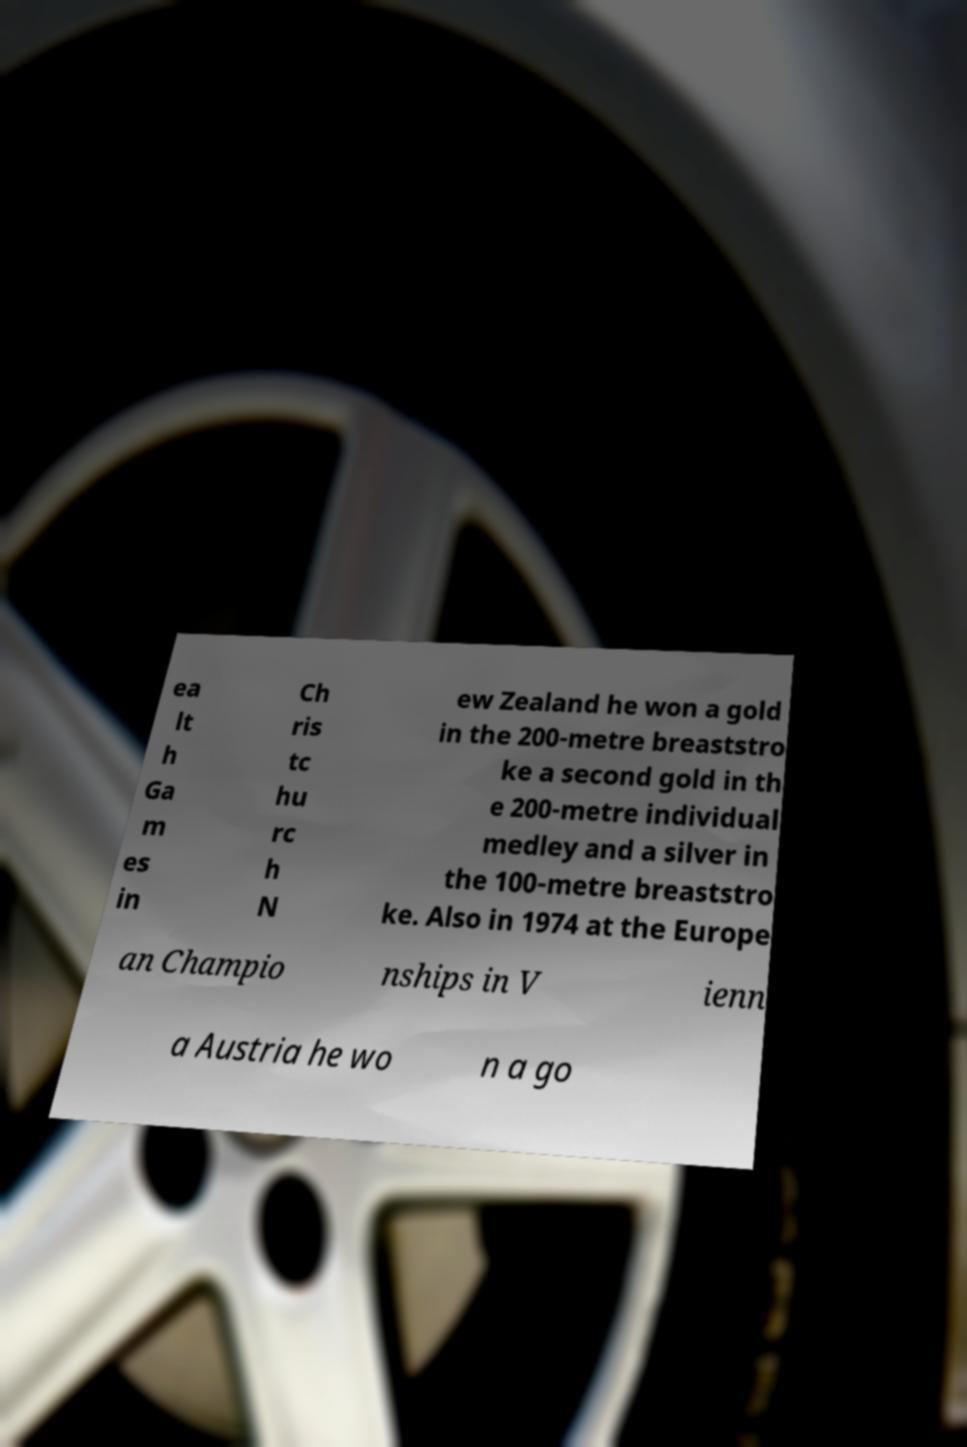There's text embedded in this image that I need extracted. Can you transcribe it verbatim? ea lt h Ga m es in Ch ris tc hu rc h N ew Zealand he won a gold in the 200-metre breaststro ke a second gold in th e 200-metre individual medley and a silver in the 100-metre breaststro ke. Also in 1974 at the Europe an Champio nships in V ienn a Austria he wo n a go 